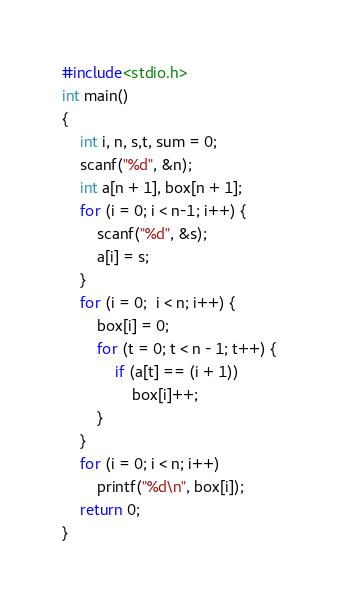<code> <loc_0><loc_0><loc_500><loc_500><_C_>#include<stdio.h>
int main()
{
	int i, n, s,t, sum = 0;
	scanf("%d", &n);
	int a[n + 1], box[n + 1];
	for (i = 0; i < n-1; i++) {
		scanf("%d", &s);
		a[i] = s;
	}
	for (i = 0;  i < n; i++) {
		box[i] = 0;
		for (t = 0; t < n - 1; t++) {
			if (a[t] == (i + 1))
				box[i]++;
		}
	}
	for (i = 0; i < n; i++)
		printf("%d\n", box[i]);
	return 0;
}</code> 